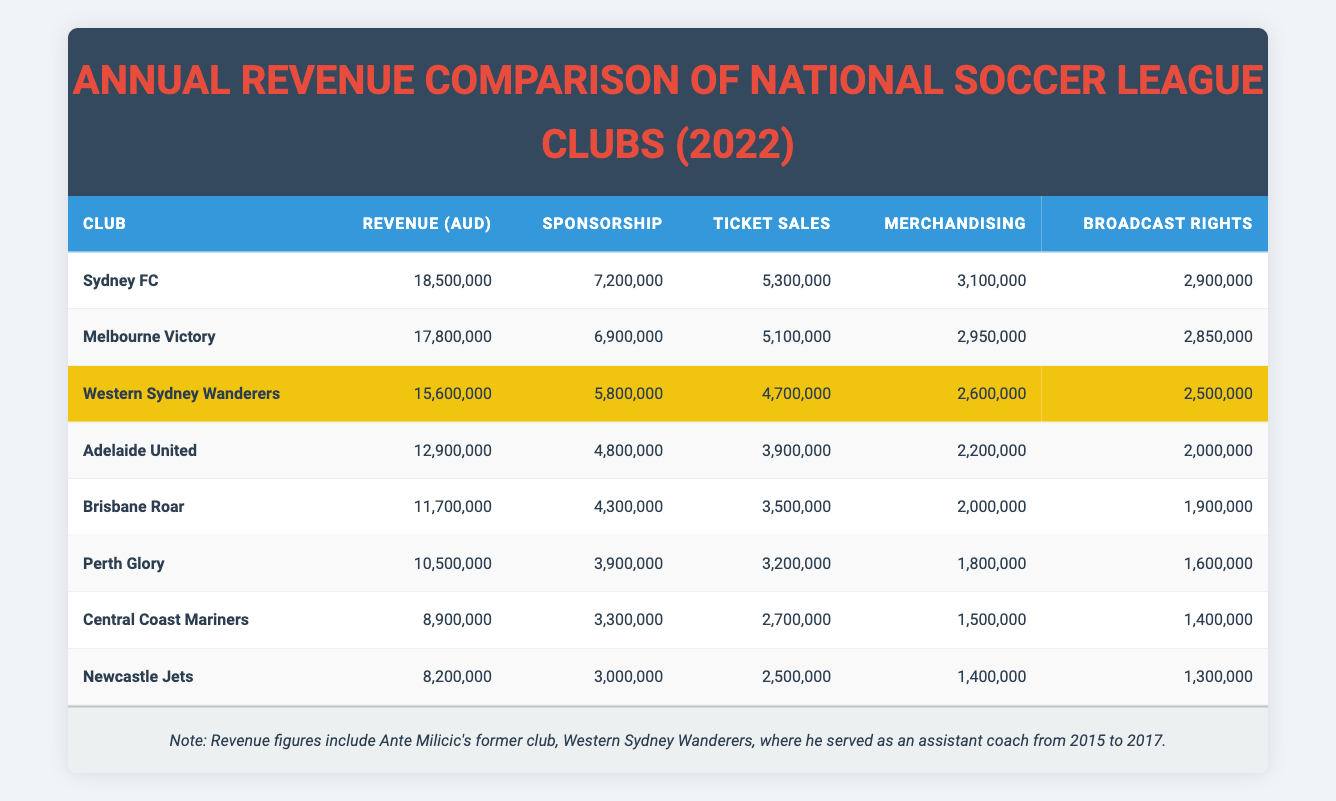What is the total revenue of Sydney FC? The table states that Sydney FC has a revenue of 18,500,000 AUD. Therefore, the total revenue for Sydney FC is simply the value presented in the table.
Answer: 18,500,000 AUD Which club has the highest ticket sales? From the table, Sydney FC has ticket sales of 5,300,000 AUD, which is greater than all other listed clubs. Thus, Sydney FC has the highest ticket sales.
Answer: Sydney FC What is the difference in revenue between Melbourne Victory and Brisbane Roar? Melbourne Victory has a revenue of 17,800,000 AUD and Brisbane Roar has a revenue of 11,700,000 AUD. The difference can be calculated by subtracting Brisbane Roar's revenue from Melbourne Victory's revenue: 17,800,000 - 11,700,000 = 6,100,000 AUD.
Answer: 6,100,000 AUD Is the sponsorship revenue of Central Coast Mariners greater than that of Adelaide United? Central Coast Mariners has a sponsorship revenue of 3,300,000 AUD, while Adelaide United has 4,800,000 AUD. Since 3,300,000 is less than 4,800,000, the statement is false.
Answer: No What is the average revenue of all clubs represented in the table? To find the average revenue, first sum all the revenues: 18,500,000 + 17,800,000 + 15,600,000 + 12,900,000 + 11,700,000 + 10,500,000 + 8,900,000 + 8,200,000 = 105,100,000 AUD. Then, divide by the number of clubs, which is 8: 105,100,000 / 8 = 13,137,500 AUD.
Answer: 13,137,500 AUD Which club has the lowest revenue and what is that amount? By inspecting the revenue column, Newcastle Jets has the lowest revenue of 8,200,000 AUD. Thus, the club with the lowest revenue is Newcastle Jets with 8,200,000 AUD.
Answer: Newcastle Jets, 8,200,000 AUD What percentage of Sydney FC's revenue comes from sponsorship? Sydney FC's revenue is 18,500,000 AUD and its sponsorship revenue is 7,200,000 AUD. To find the percentage, divide the sponsorship revenue by total revenue and multiply by 100: (7,200,000 / 18,500,000) * 100 ≈ 38.92%.
Answer: Approximately 38.92% Are the ticket sales of Perth Glory higher than those of Western Sydney Wanderers? Perth Glory's ticket sales are 3,200,000 AUD, while Western Sydney Wanderers have ticket sales of 4,700,000 AUD. Since 3,200,000 is less than 4,700,000, the ticket sales of Perth Glory are lower.
Answer: No What is the total merchandising revenue of all clubs combined? To calculate the total merchandising revenue, sum the merchandising values: 3,100,000 + 2,950,000 + 2,600,000 + 2,200,000 + 2,000,000 + 1,800,000 + 1,500,000 + 1,400,000 = 17,050,000 AUD.
Answer: 17,050,000 AUD 